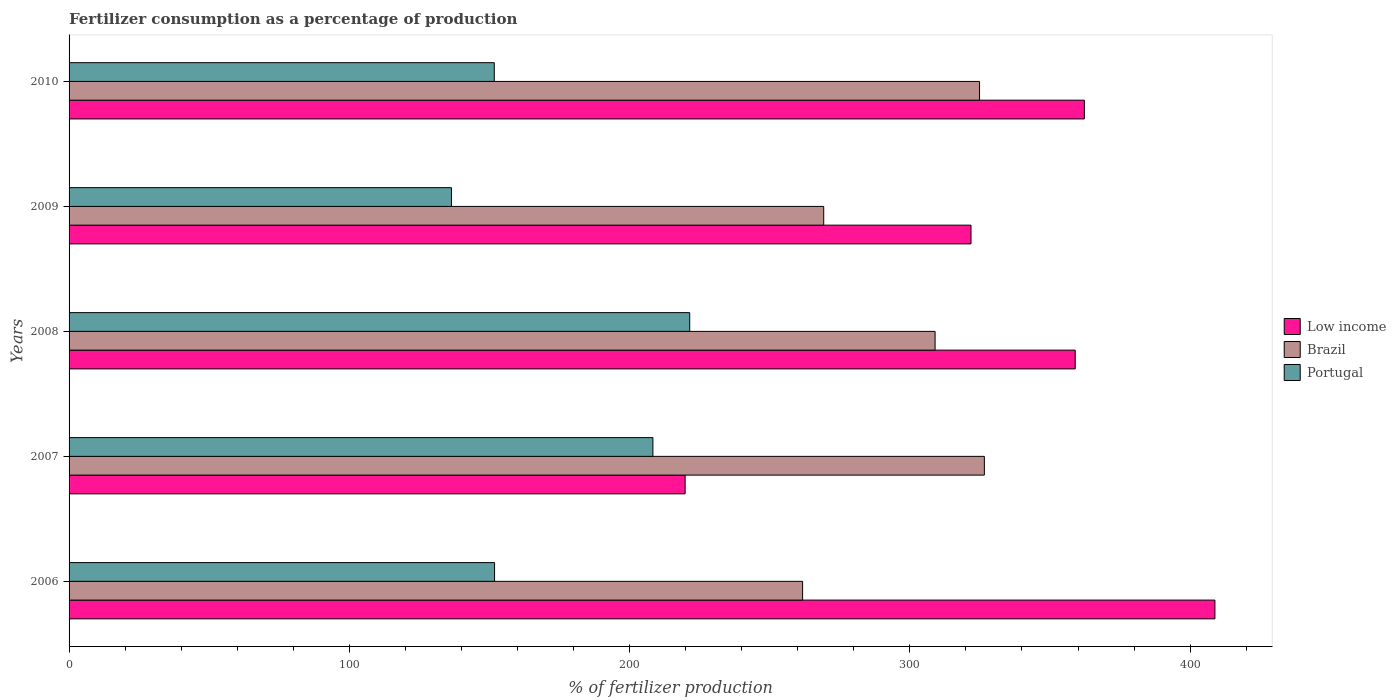How many different coloured bars are there?
Offer a very short reply. 3. Are the number of bars on each tick of the Y-axis equal?
Keep it short and to the point. Yes. In how many cases, is the number of bars for a given year not equal to the number of legend labels?
Your response must be concise. 0. What is the percentage of fertilizers consumed in Portugal in 2009?
Offer a very short reply. 136.43. Across all years, what is the maximum percentage of fertilizers consumed in Low income?
Keep it short and to the point. 408.85. Across all years, what is the minimum percentage of fertilizers consumed in Portugal?
Offer a very short reply. 136.43. In which year was the percentage of fertilizers consumed in Portugal minimum?
Make the answer very short. 2009. What is the total percentage of fertilizers consumed in Portugal in the graph?
Ensure brevity in your answer.  869.74. What is the difference between the percentage of fertilizers consumed in Portugal in 2006 and that in 2008?
Provide a succinct answer. -69.63. What is the difference between the percentage of fertilizers consumed in Low income in 2010 and the percentage of fertilizers consumed in Portugal in 2008?
Provide a succinct answer. 140.82. What is the average percentage of fertilizers consumed in Brazil per year?
Provide a short and direct response. 298.29. In the year 2007, what is the difference between the percentage of fertilizers consumed in Portugal and percentage of fertilizers consumed in Brazil?
Provide a succinct answer. -118.26. In how many years, is the percentage of fertilizers consumed in Brazil greater than 360 %?
Your response must be concise. 0. What is the ratio of the percentage of fertilizers consumed in Brazil in 2006 to that in 2007?
Your answer should be compact. 0.8. Is the percentage of fertilizers consumed in Low income in 2007 less than that in 2009?
Your answer should be compact. Yes. Is the difference between the percentage of fertilizers consumed in Portugal in 2006 and 2007 greater than the difference between the percentage of fertilizers consumed in Brazil in 2006 and 2007?
Make the answer very short. Yes. What is the difference between the highest and the second highest percentage of fertilizers consumed in Brazil?
Provide a short and direct response. 1.72. What is the difference between the highest and the lowest percentage of fertilizers consumed in Brazil?
Your response must be concise. 64.85. In how many years, is the percentage of fertilizers consumed in Low income greater than the average percentage of fertilizers consumed in Low income taken over all years?
Keep it short and to the point. 3. What does the 2nd bar from the bottom in 2006 represents?
Provide a short and direct response. Brazil. Is it the case that in every year, the sum of the percentage of fertilizers consumed in Low income and percentage of fertilizers consumed in Brazil is greater than the percentage of fertilizers consumed in Portugal?
Provide a succinct answer. Yes. How many bars are there?
Ensure brevity in your answer.  15. Are all the bars in the graph horizontal?
Provide a short and direct response. Yes. What is the difference between two consecutive major ticks on the X-axis?
Give a very brief answer. 100. How many legend labels are there?
Your answer should be compact. 3. What is the title of the graph?
Provide a succinct answer. Fertilizer consumption as a percentage of production. What is the label or title of the X-axis?
Offer a terse response. % of fertilizer production. What is the % of fertilizer production of Low income in 2006?
Your response must be concise. 408.85. What is the % of fertilizer production in Brazil in 2006?
Provide a succinct answer. 261.74. What is the % of fertilizer production in Portugal in 2006?
Your response must be concise. 151.82. What is the % of fertilizer production of Low income in 2007?
Your answer should be compact. 219.81. What is the % of fertilizer production of Brazil in 2007?
Your answer should be very brief. 326.59. What is the % of fertilizer production of Portugal in 2007?
Offer a very short reply. 208.32. What is the % of fertilizer production in Low income in 2008?
Your answer should be very brief. 359.01. What is the % of fertilizer production of Brazil in 2008?
Provide a short and direct response. 309.01. What is the % of fertilizer production in Portugal in 2008?
Your answer should be compact. 221.45. What is the % of fertilizer production in Low income in 2009?
Ensure brevity in your answer.  321.82. What is the % of fertilizer production in Brazil in 2009?
Keep it short and to the point. 269.27. What is the % of fertilizer production in Portugal in 2009?
Your answer should be compact. 136.43. What is the % of fertilizer production of Low income in 2010?
Your answer should be compact. 362.27. What is the % of fertilizer production of Brazil in 2010?
Provide a short and direct response. 324.87. What is the % of fertilizer production of Portugal in 2010?
Your answer should be very brief. 151.72. Across all years, what is the maximum % of fertilizer production of Low income?
Make the answer very short. 408.85. Across all years, what is the maximum % of fertilizer production of Brazil?
Your answer should be very brief. 326.59. Across all years, what is the maximum % of fertilizer production in Portugal?
Offer a terse response. 221.45. Across all years, what is the minimum % of fertilizer production of Low income?
Provide a succinct answer. 219.81. Across all years, what is the minimum % of fertilizer production in Brazil?
Provide a succinct answer. 261.74. Across all years, what is the minimum % of fertilizer production in Portugal?
Your response must be concise. 136.43. What is the total % of fertilizer production in Low income in the graph?
Your answer should be compact. 1671.76. What is the total % of fertilizer production of Brazil in the graph?
Make the answer very short. 1491.47. What is the total % of fertilizer production in Portugal in the graph?
Make the answer very short. 869.74. What is the difference between the % of fertilizer production in Low income in 2006 and that in 2007?
Offer a very short reply. 189.04. What is the difference between the % of fertilizer production of Brazil in 2006 and that in 2007?
Provide a short and direct response. -64.85. What is the difference between the % of fertilizer production in Portugal in 2006 and that in 2007?
Your answer should be very brief. -56.5. What is the difference between the % of fertilizer production of Low income in 2006 and that in 2008?
Provide a short and direct response. 49.84. What is the difference between the % of fertilizer production in Brazil in 2006 and that in 2008?
Keep it short and to the point. -47.27. What is the difference between the % of fertilizer production in Portugal in 2006 and that in 2008?
Provide a succinct answer. -69.63. What is the difference between the % of fertilizer production of Low income in 2006 and that in 2009?
Give a very brief answer. 87.03. What is the difference between the % of fertilizer production of Brazil in 2006 and that in 2009?
Provide a succinct answer. -7.53. What is the difference between the % of fertilizer production in Portugal in 2006 and that in 2009?
Offer a very short reply. 15.39. What is the difference between the % of fertilizer production in Low income in 2006 and that in 2010?
Make the answer very short. 46.58. What is the difference between the % of fertilizer production in Brazil in 2006 and that in 2010?
Provide a short and direct response. -63.13. What is the difference between the % of fertilizer production of Portugal in 2006 and that in 2010?
Ensure brevity in your answer.  0.11. What is the difference between the % of fertilizer production of Low income in 2007 and that in 2008?
Your answer should be compact. -139.19. What is the difference between the % of fertilizer production of Brazil in 2007 and that in 2008?
Your answer should be very brief. 17.58. What is the difference between the % of fertilizer production in Portugal in 2007 and that in 2008?
Give a very brief answer. -13.13. What is the difference between the % of fertilizer production in Low income in 2007 and that in 2009?
Offer a very short reply. -102.01. What is the difference between the % of fertilizer production of Brazil in 2007 and that in 2009?
Your answer should be very brief. 57.32. What is the difference between the % of fertilizer production in Portugal in 2007 and that in 2009?
Your answer should be compact. 71.89. What is the difference between the % of fertilizer production in Low income in 2007 and that in 2010?
Give a very brief answer. -142.46. What is the difference between the % of fertilizer production of Brazil in 2007 and that in 2010?
Your response must be concise. 1.72. What is the difference between the % of fertilizer production of Portugal in 2007 and that in 2010?
Keep it short and to the point. 56.61. What is the difference between the % of fertilizer production of Low income in 2008 and that in 2009?
Offer a very short reply. 37.19. What is the difference between the % of fertilizer production of Brazil in 2008 and that in 2009?
Make the answer very short. 39.74. What is the difference between the % of fertilizer production of Portugal in 2008 and that in 2009?
Keep it short and to the point. 85.02. What is the difference between the % of fertilizer production in Low income in 2008 and that in 2010?
Make the answer very short. -3.26. What is the difference between the % of fertilizer production in Brazil in 2008 and that in 2010?
Offer a terse response. -15.86. What is the difference between the % of fertilizer production of Portugal in 2008 and that in 2010?
Your response must be concise. 69.74. What is the difference between the % of fertilizer production of Low income in 2009 and that in 2010?
Your answer should be very brief. -40.45. What is the difference between the % of fertilizer production of Brazil in 2009 and that in 2010?
Your response must be concise. -55.6. What is the difference between the % of fertilizer production of Portugal in 2009 and that in 2010?
Offer a terse response. -15.28. What is the difference between the % of fertilizer production of Low income in 2006 and the % of fertilizer production of Brazil in 2007?
Offer a terse response. 82.27. What is the difference between the % of fertilizer production in Low income in 2006 and the % of fertilizer production in Portugal in 2007?
Keep it short and to the point. 200.53. What is the difference between the % of fertilizer production of Brazil in 2006 and the % of fertilizer production of Portugal in 2007?
Make the answer very short. 53.42. What is the difference between the % of fertilizer production in Low income in 2006 and the % of fertilizer production in Brazil in 2008?
Keep it short and to the point. 99.84. What is the difference between the % of fertilizer production of Low income in 2006 and the % of fertilizer production of Portugal in 2008?
Make the answer very short. 187.4. What is the difference between the % of fertilizer production in Brazil in 2006 and the % of fertilizer production in Portugal in 2008?
Your response must be concise. 40.28. What is the difference between the % of fertilizer production in Low income in 2006 and the % of fertilizer production in Brazil in 2009?
Offer a terse response. 139.59. What is the difference between the % of fertilizer production of Low income in 2006 and the % of fertilizer production of Portugal in 2009?
Offer a terse response. 272.42. What is the difference between the % of fertilizer production in Brazil in 2006 and the % of fertilizer production in Portugal in 2009?
Your answer should be very brief. 125.31. What is the difference between the % of fertilizer production in Low income in 2006 and the % of fertilizer production in Brazil in 2010?
Your answer should be very brief. 83.98. What is the difference between the % of fertilizer production in Low income in 2006 and the % of fertilizer production in Portugal in 2010?
Offer a very short reply. 257.14. What is the difference between the % of fertilizer production in Brazil in 2006 and the % of fertilizer production in Portugal in 2010?
Give a very brief answer. 110.02. What is the difference between the % of fertilizer production of Low income in 2007 and the % of fertilizer production of Brazil in 2008?
Offer a terse response. -89.2. What is the difference between the % of fertilizer production in Low income in 2007 and the % of fertilizer production in Portugal in 2008?
Your answer should be very brief. -1.64. What is the difference between the % of fertilizer production in Brazil in 2007 and the % of fertilizer production in Portugal in 2008?
Make the answer very short. 105.13. What is the difference between the % of fertilizer production of Low income in 2007 and the % of fertilizer production of Brazil in 2009?
Offer a terse response. -49.45. What is the difference between the % of fertilizer production in Low income in 2007 and the % of fertilizer production in Portugal in 2009?
Make the answer very short. 83.38. What is the difference between the % of fertilizer production in Brazil in 2007 and the % of fertilizer production in Portugal in 2009?
Your response must be concise. 190.16. What is the difference between the % of fertilizer production in Low income in 2007 and the % of fertilizer production in Brazil in 2010?
Ensure brevity in your answer.  -105.06. What is the difference between the % of fertilizer production in Low income in 2007 and the % of fertilizer production in Portugal in 2010?
Give a very brief answer. 68.1. What is the difference between the % of fertilizer production of Brazil in 2007 and the % of fertilizer production of Portugal in 2010?
Your answer should be very brief. 174.87. What is the difference between the % of fertilizer production in Low income in 2008 and the % of fertilizer production in Brazil in 2009?
Your answer should be compact. 89.74. What is the difference between the % of fertilizer production in Low income in 2008 and the % of fertilizer production in Portugal in 2009?
Keep it short and to the point. 222.58. What is the difference between the % of fertilizer production of Brazil in 2008 and the % of fertilizer production of Portugal in 2009?
Your answer should be very brief. 172.58. What is the difference between the % of fertilizer production in Low income in 2008 and the % of fertilizer production in Brazil in 2010?
Give a very brief answer. 34.14. What is the difference between the % of fertilizer production of Low income in 2008 and the % of fertilizer production of Portugal in 2010?
Keep it short and to the point. 207.29. What is the difference between the % of fertilizer production of Brazil in 2008 and the % of fertilizer production of Portugal in 2010?
Your response must be concise. 157.29. What is the difference between the % of fertilizer production of Low income in 2009 and the % of fertilizer production of Brazil in 2010?
Your answer should be compact. -3.05. What is the difference between the % of fertilizer production in Low income in 2009 and the % of fertilizer production in Portugal in 2010?
Ensure brevity in your answer.  170.11. What is the difference between the % of fertilizer production in Brazil in 2009 and the % of fertilizer production in Portugal in 2010?
Your response must be concise. 117.55. What is the average % of fertilizer production in Low income per year?
Provide a short and direct response. 334.35. What is the average % of fertilizer production of Brazil per year?
Your response must be concise. 298.29. What is the average % of fertilizer production in Portugal per year?
Ensure brevity in your answer.  173.95. In the year 2006, what is the difference between the % of fertilizer production in Low income and % of fertilizer production in Brazil?
Provide a succinct answer. 147.12. In the year 2006, what is the difference between the % of fertilizer production of Low income and % of fertilizer production of Portugal?
Keep it short and to the point. 257.03. In the year 2006, what is the difference between the % of fertilizer production in Brazil and % of fertilizer production in Portugal?
Your answer should be very brief. 109.92. In the year 2007, what is the difference between the % of fertilizer production of Low income and % of fertilizer production of Brazil?
Provide a short and direct response. -106.77. In the year 2007, what is the difference between the % of fertilizer production in Low income and % of fertilizer production in Portugal?
Your answer should be very brief. 11.49. In the year 2007, what is the difference between the % of fertilizer production of Brazil and % of fertilizer production of Portugal?
Keep it short and to the point. 118.26. In the year 2008, what is the difference between the % of fertilizer production of Low income and % of fertilizer production of Brazil?
Your response must be concise. 50. In the year 2008, what is the difference between the % of fertilizer production of Low income and % of fertilizer production of Portugal?
Offer a terse response. 137.56. In the year 2008, what is the difference between the % of fertilizer production in Brazil and % of fertilizer production in Portugal?
Offer a terse response. 87.56. In the year 2009, what is the difference between the % of fertilizer production of Low income and % of fertilizer production of Brazil?
Offer a terse response. 52.55. In the year 2009, what is the difference between the % of fertilizer production in Low income and % of fertilizer production in Portugal?
Provide a short and direct response. 185.39. In the year 2009, what is the difference between the % of fertilizer production in Brazil and % of fertilizer production in Portugal?
Keep it short and to the point. 132.84. In the year 2010, what is the difference between the % of fertilizer production in Low income and % of fertilizer production in Brazil?
Your response must be concise. 37.4. In the year 2010, what is the difference between the % of fertilizer production of Low income and % of fertilizer production of Portugal?
Make the answer very short. 210.56. In the year 2010, what is the difference between the % of fertilizer production in Brazil and % of fertilizer production in Portugal?
Provide a short and direct response. 173.15. What is the ratio of the % of fertilizer production in Low income in 2006 to that in 2007?
Offer a very short reply. 1.86. What is the ratio of the % of fertilizer production in Brazil in 2006 to that in 2007?
Provide a succinct answer. 0.8. What is the ratio of the % of fertilizer production in Portugal in 2006 to that in 2007?
Your answer should be compact. 0.73. What is the ratio of the % of fertilizer production of Low income in 2006 to that in 2008?
Keep it short and to the point. 1.14. What is the ratio of the % of fertilizer production in Brazil in 2006 to that in 2008?
Make the answer very short. 0.85. What is the ratio of the % of fertilizer production in Portugal in 2006 to that in 2008?
Provide a short and direct response. 0.69. What is the ratio of the % of fertilizer production of Low income in 2006 to that in 2009?
Ensure brevity in your answer.  1.27. What is the ratio of the % of fertilizer production in Brazil in 2006 to that in 2009?
Your response must be concise. 0.97. What is the ratio of the % of fertilizer production in Portugal in 2006 to that in 2009?
Your answer should be very brief. 1.11. What is the ratio of the % of fertilizer production in Low income in 2006 to that in 2010?
Offer a terse response. 1.13. What is the ratio of the % of fertilizer production of Brazil in 2006 to that in 2010?
Provide a succinct answer. 0.81. What is the ratio of the % of fertilizer production of Portugal in 2006 to that in 2010?
Keep it short and to the point. 1. What is the ratio of the % of fertilizer production of Low income in 2007 to that in 2008?
Keep it short and to the point. 0.61. What is the ratio of the % of fertilizer production of Brazil in 2007 to that in 2008?
Ensure brevity in your answer.  1.06. What is the ratio of the % of fertilizer production in Portugal in 2007 to that in 2008?
Provide a succinct answer. 0.94. What is the ratio of the % of fertilizer production in Low income in 2007 to that in 2009?
Your response must be concise. 0.68. What is the ratio of the % of fertilizer production in Brazil in 2007 to that in 2009?
Provide a short and direct response. 1.21. What is the ratio of the % of fertilizer production in Portugal in 2007 to that in 2009?
Provide a short and direct response. 1.53. What is the ratio of the % of fertilizer production of Low income in 2007 to that in 2010?
Provide a short and direct response. 0.61. What is the ratio of the % of fertilizer production of Brazil in 2007 to that in 2010?
Your answer should be very brief. 1.01. What is the ratio of the % of fertilizer production of Portugal in 2007 to that in 2010?
Keep it short and to the point. 1.37. What is the ratio of the % of fertilizer production in Low income in 2008 to that in 2009?
Your answer should be compact. 1.12. What is the ratio of the % of fertilizer production of Brazil in 2008 to that in 2009?
Your response must be concise. 1.15. What is the ratio of the % of fertilizer production in Portugal in 2008 to that in 2009?
Provide a short and direct response. 1.62. What is the ratio of the % of fertilizer production of Low income in 2008 to that in 2010?
Ensure brevity in your answer.  0.99. What is the ratio of the % of fertilizer production in Brazil in 2008 to that in 2010?
Your answer should be very brief. 0.95. What is the ratio of the % of fertilizer production of Portugal in 2008 to that in 2010?
Offer a terse response. 1.46. What is the ratio of the % of fertilizer production of Low income in 2009 to that in 2010?
Your response must be concise. 0.89. What is the ratio of the % of fertilizer production in Brazil in 2009 to that in 2010?
Provide a succinct answer. 0.83. What is the ratio of the % of fertilizer production of Portugal in 2009 to that in 2010?
Provide a succinct answer. 0.9. What is the difference between the highest and the second highest % of fertilizer production of Low income?
Your answer should be very brief. 46.58. What is the difference between the highest and the second highest % of fertilizer production in Brazil?
Give a very brief answer. 1.72. What is the difference between the highest and the second highest % of fertilizer production of Portugal?
Give a very brief answer. 13.13. What is the difference between the highest and the lowest % of fertilizer production in Low income?
Provide a succinct answer. 189.04. What is the difference between the highest and the lowest % of fertilizer production in Brazil?
Make the answer very short. 64.85. What is the difference between the highest and the lowest % of fertilizer production in Portugal?
Your response must be concise. 85.02. 